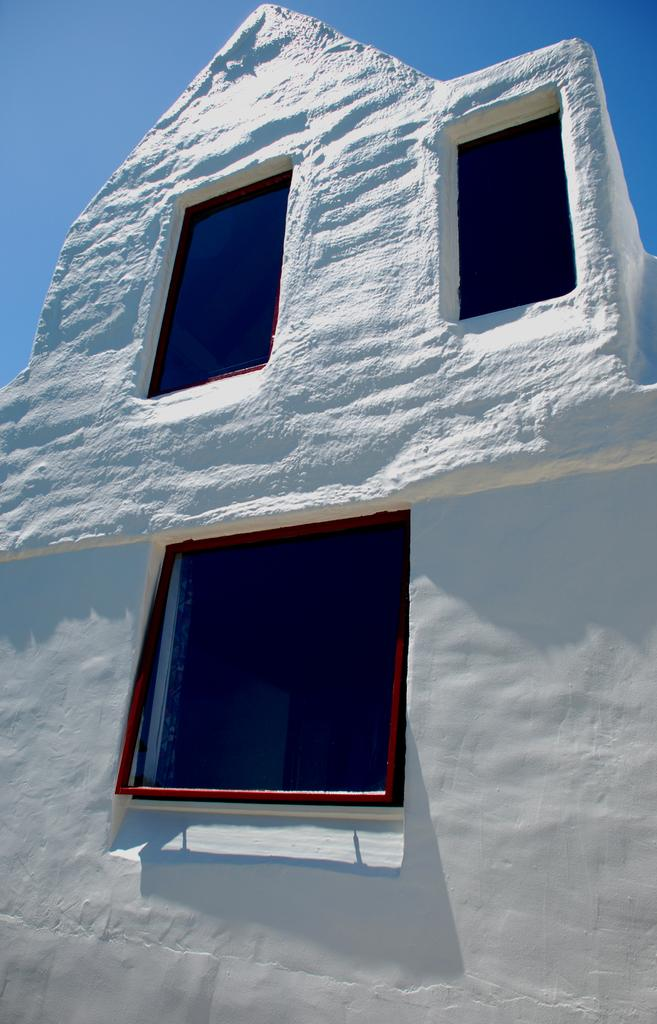What is the main subject in the foreground of the image? There is a building in the foreground of the image. How many windows are visible on the building? The building has three windows. What is visible at the top of the image? The sky is visible at the top of the image. Can you see a fan attached to the building in the image? There is no fan visible on the building in the image. What type of root system can be seen growing from the building in the image? There is no root system visible on the building in the image. 